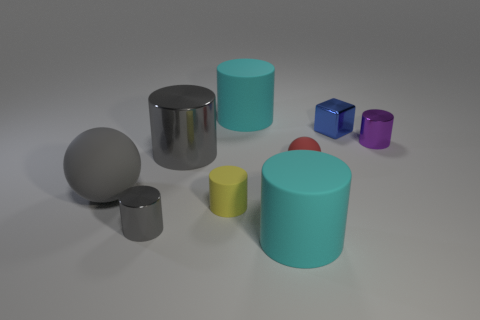Subtract all tiny metal cylinders. How many cylinders are left? 4 Subtract all purple cylinders. How many cylinders are left? 5 Subtract 1 cylinders. How many cylinders are left? 5 Subtract all red cylinders. Subtract all yellow cubes. How many cylinders are left? 6 Subtract all cylinders. How many objects are left? 3 Subtract 0 green cylinders. How many objects are left? 9 Subtract all yellow objects. Subtract all red balls. How many objects are left? 7 Add 5 rubber cylinders. How many rubber cylinders are left? 8 Add 1 tiny things. How many tiny things exist? 6 